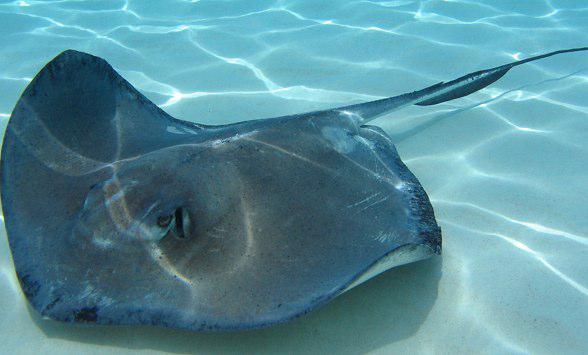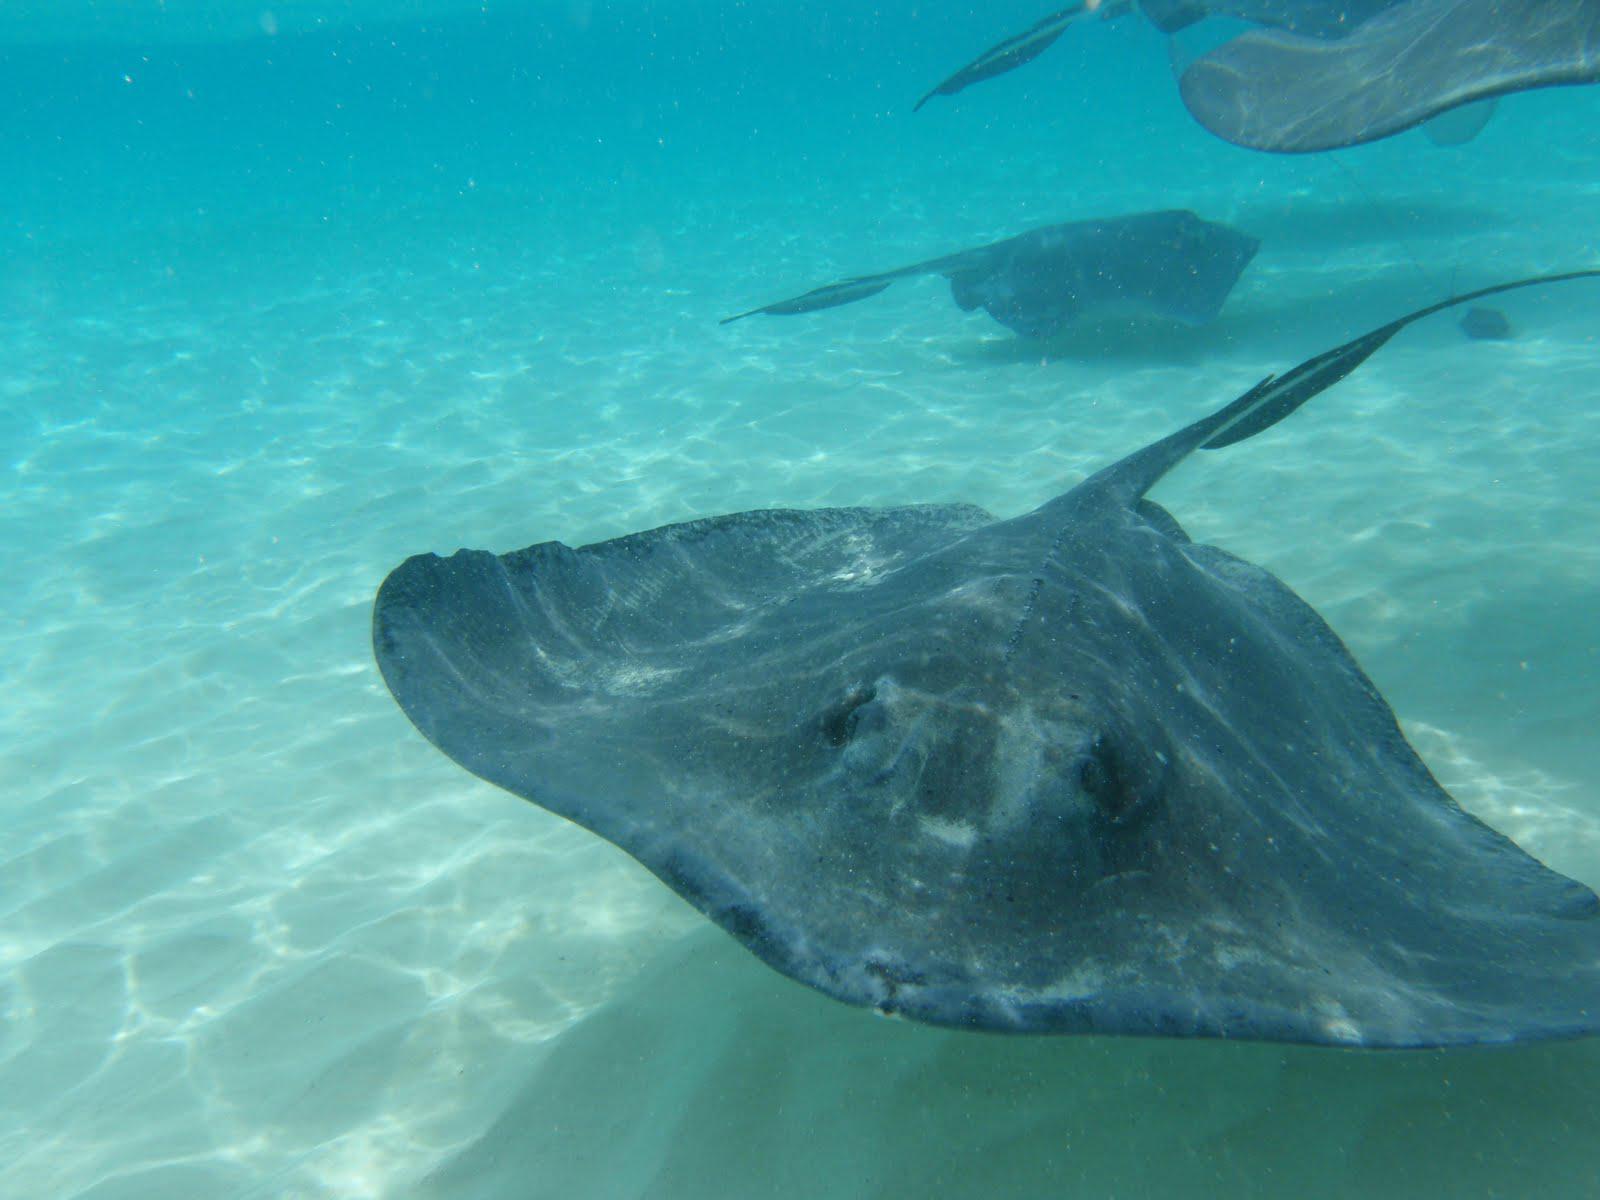The first image is the image on the left, the second image is the image on the right. For the images displayed, is the sentence "The stingray on the left is viewed from underneath, showing its underside." factually correct? Answer yes or no. No. 